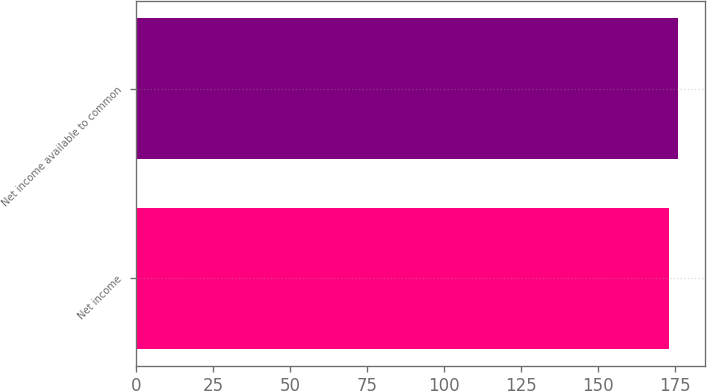<chart> <loc_0><loc_0><loc_500><loc_500><bar_chart><fcel>Net income<fcel>Net income available to common<nl><fcel>173<fcel>176<nl></chart> 